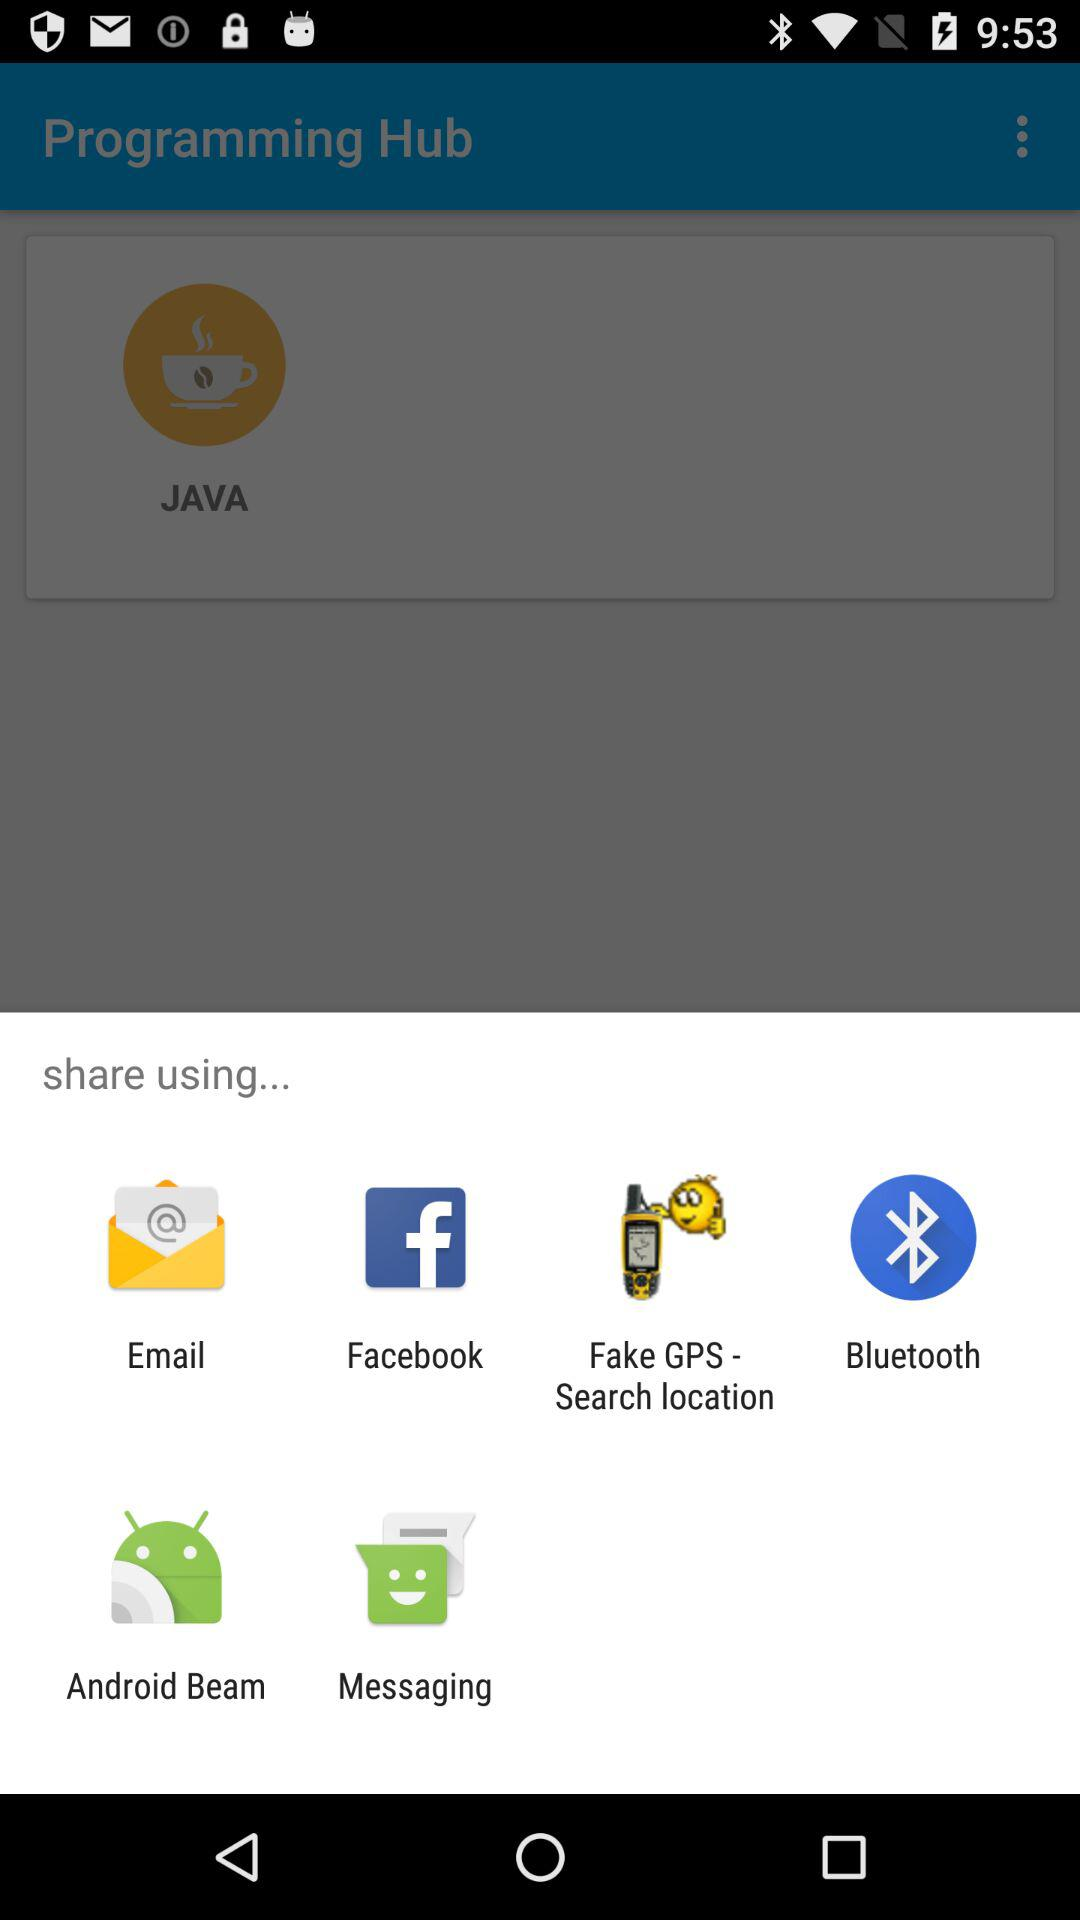What is the user's name?
When the provided information is insufficient, respond with <no answer>. <no answer> 